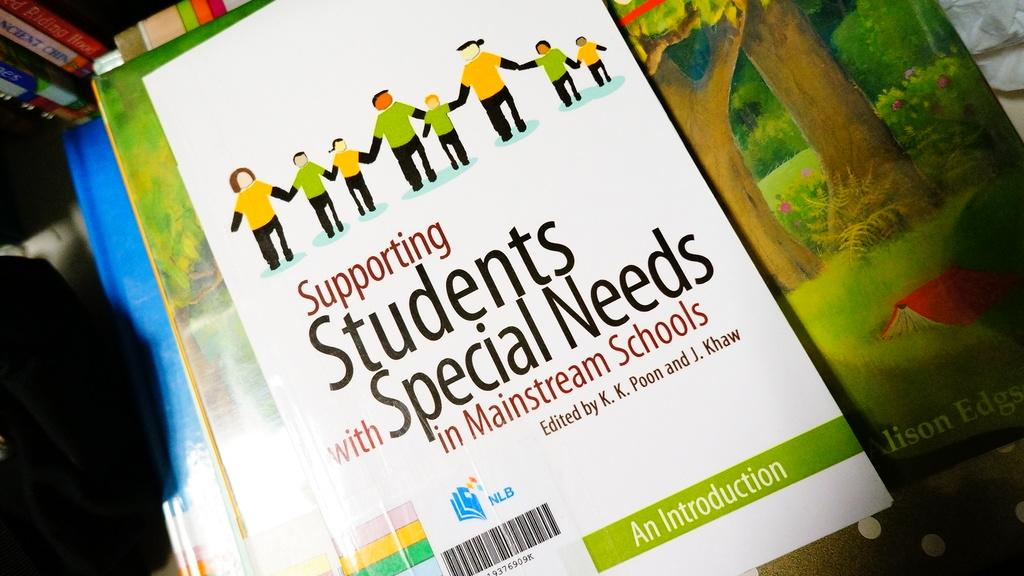Provide a one-sentence caption for the provided image. book on supporting student special needs for a teacher. 